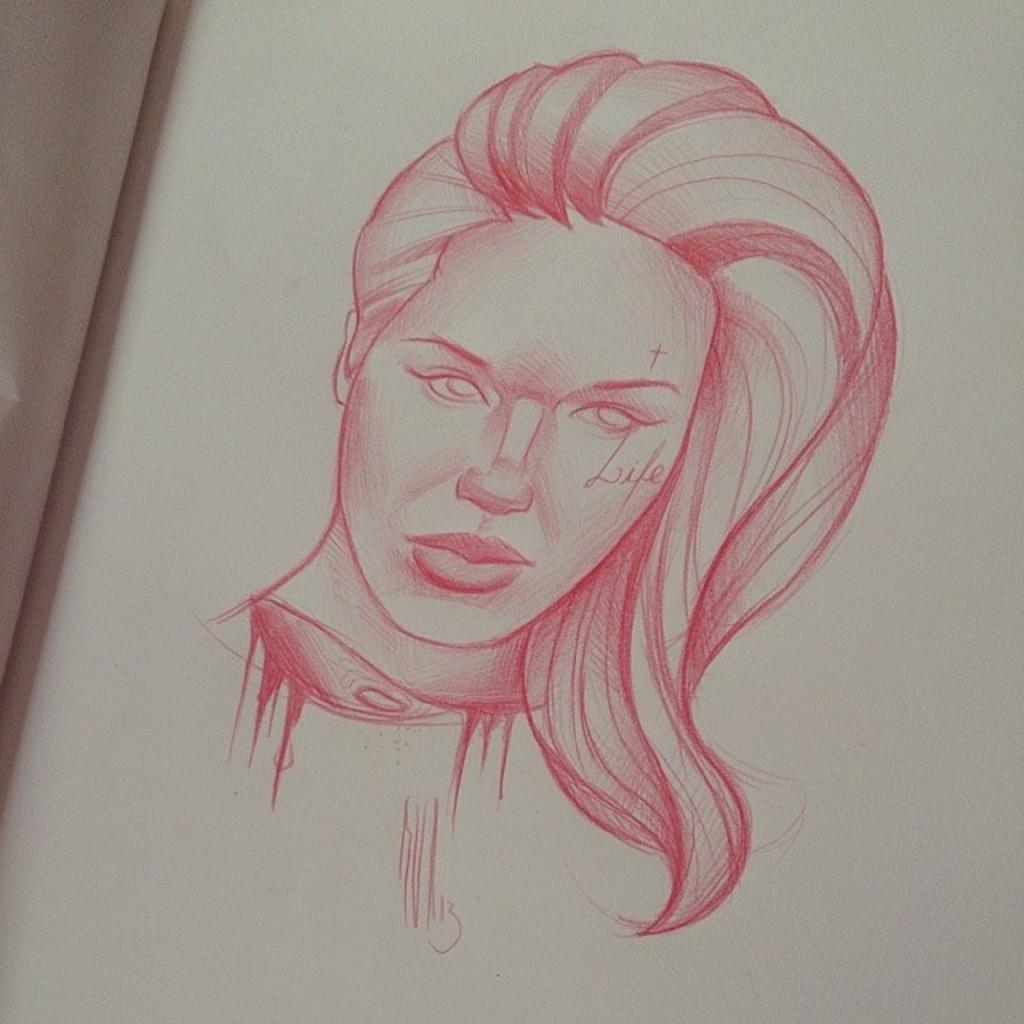What is depicted in the image? There is a drawing of a person in the image. What type of whip is being used by the person in the drawing? There is no whip present in the image; it only features a drawing of a person. 